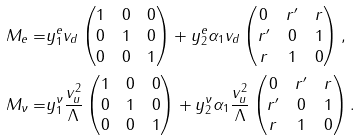<formula> <loc_0><loc_0><loc_500><loc_500>M _ { e } = & y _ { 1 } ^ { e } v _ { d } \begin{pmatrix} 1 & 0 & 0 \\ 0 & 1 & 0 \\ 0 & 0 & 1 \\ \end{pmatrix} + y _ { 2 } ^ { e } \alpha _ { 1 } v _ { d } \begin{pmatrix} 0 & r ^ { \prime } & r \\ r ^ { \prime } & 0 & 1 \\ r & 1 & 0 \end{pmatrix} , \\ M _ { \nu } = & y _ { 1 } ^ { \nu } \frac { v _ { u } ^ { 2 } } { \Lambda } \begin{pmatrix} 1 & 0 & 0 \\ 0 & 1 & 0 \\ 0 & 0 & 1 \\ \end{pmatrix} + y _ { 2 } ^ { \nu } \alpha _ { 1 } \frac { v _ { u } ^ { 2 } } { \Lambda } \begin{pmatrix} 0 & r ^ { \prime } & r \\ r ^ { \prime } & 0 & 1 \\ r & 1 & 0 \end{pmatrix} .</formula> 